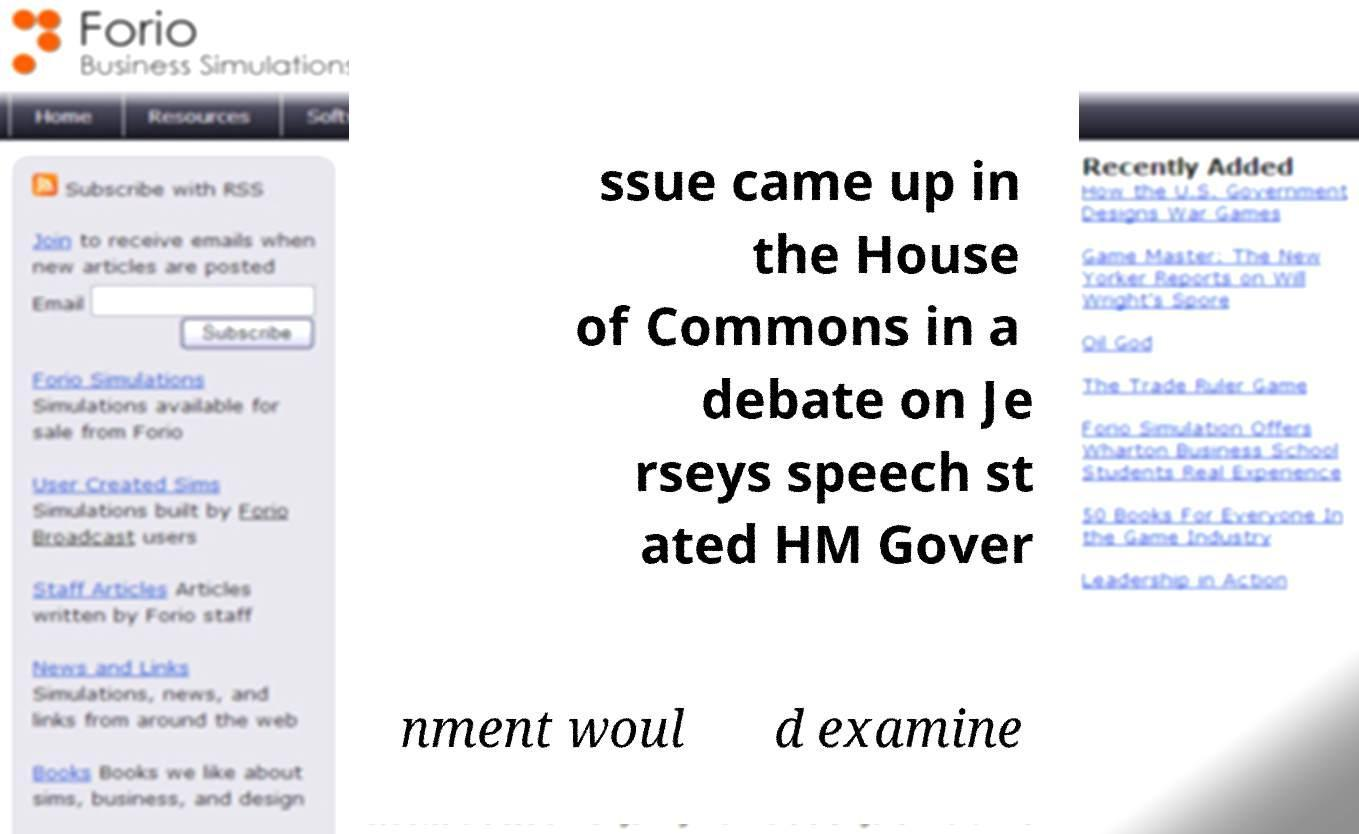For documentation purposes, I need the text within this image transcribed. Could you provide that? ssue came up in the House of Commons in a debate on Je rseys speech st ated HM Gover nment woul d examine 